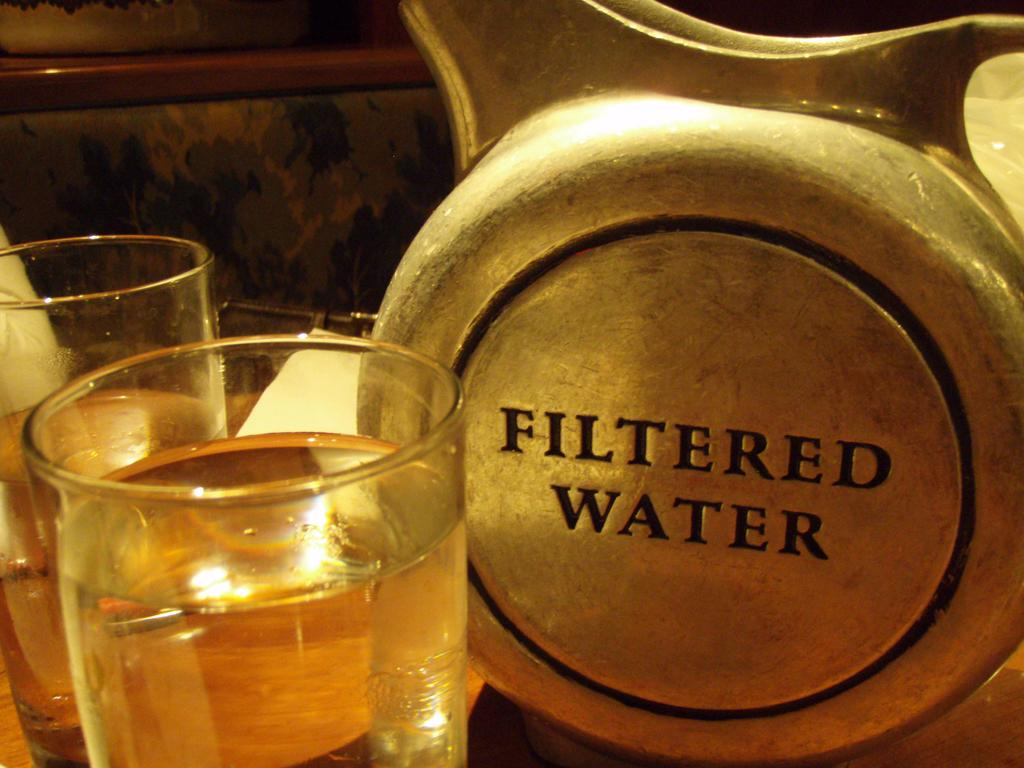Provide a one-sentence caption for the provided image. A silver container that says Filtered Water is next to two glasses of water. 